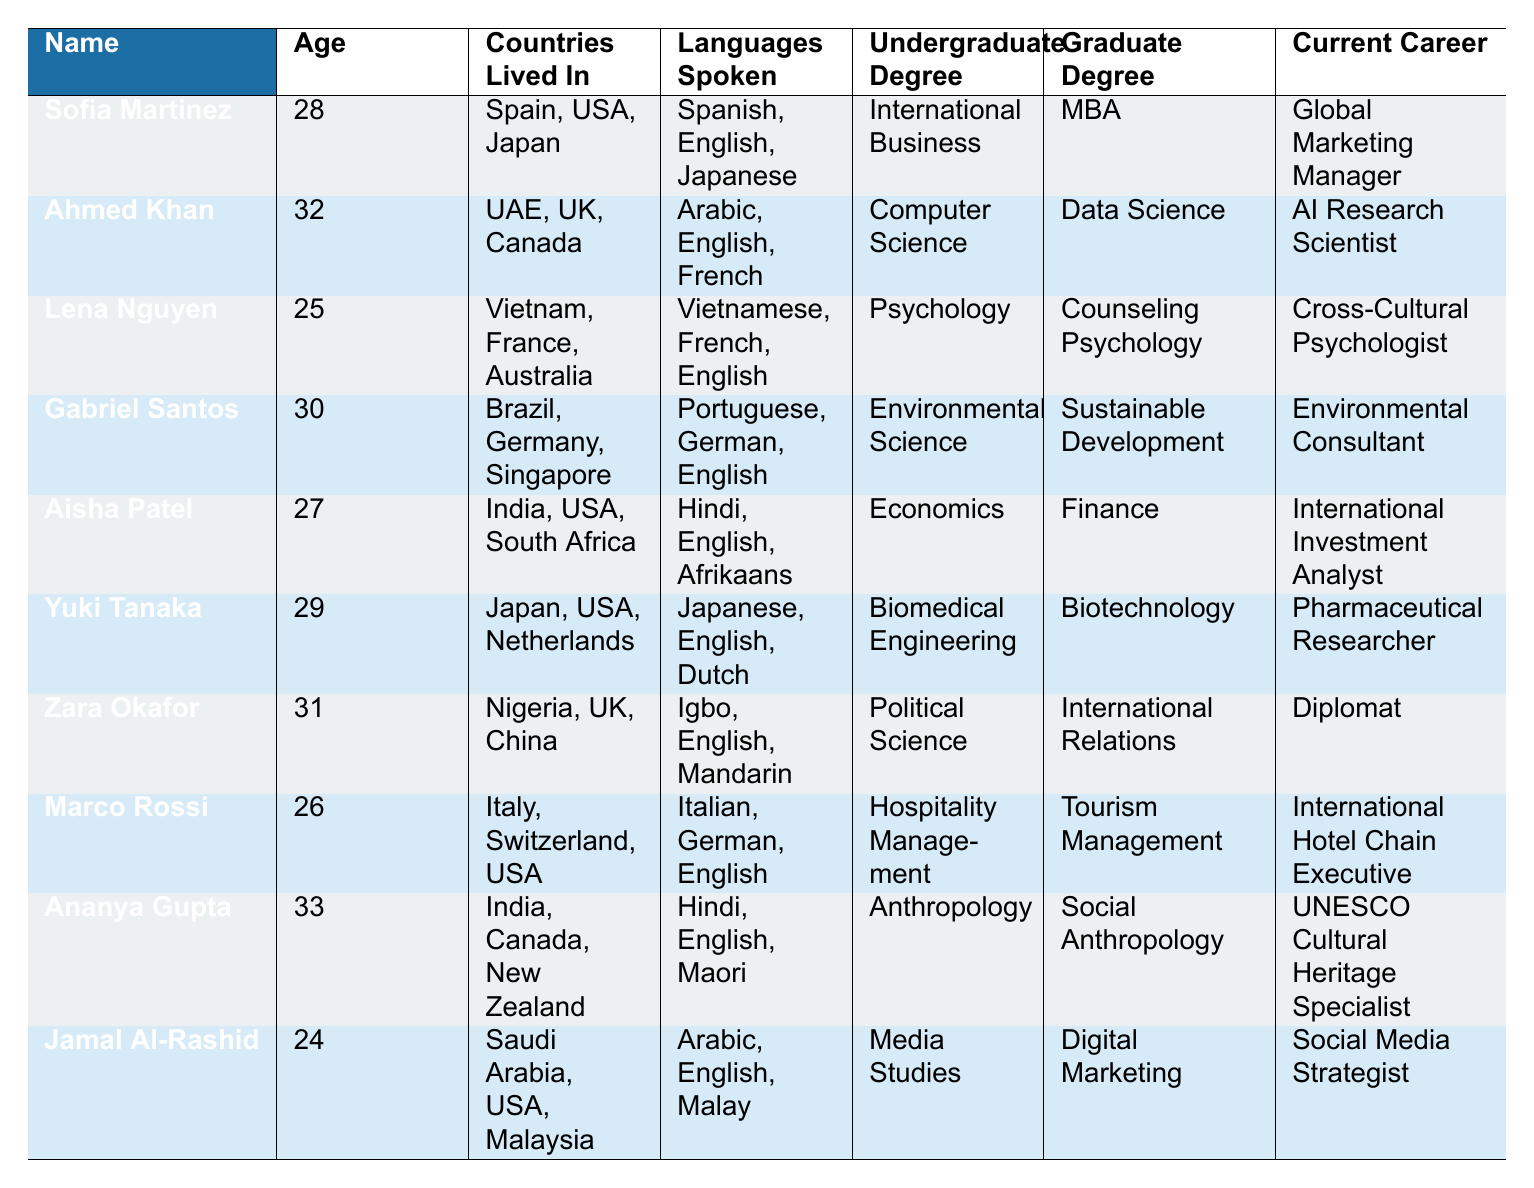What is the current career of Lena Nguyen? Lena Nguyen's current career is listed in the table under the "Current Career" column. It indicates that she is a "Cross-Cultural Psychologist."
Answer: Cross-Cultural Psychologist How many individuals in the table are involved in careers related to international relations? The table lists Zara Okafor as a "Diplomat" and Ananya Gupta as a "UNESCO Cultural Heritage Specialist," both of which relate to international relations. Adding these, there are 2 people in such careers.
Answer: 2 Which individual has the highest age in this group? The ages of all individuals were reviewed, with Ananya Gupta at 33 being the highest age among the entries shown.
Answer: Ananya Gupta Is Yuki Tanaka currently involved in the health sector? Yuki Tanaka's current career is a "Pharmaceutical Researcher," which indeed pertains to the health sector, indicating a true answer.
Answer: Yes What is the average age of individuals in the table? To calculate the average age, sum the ages: 28 + 32 + 25 + 30 + 27 + 29 + 31 + 26 + 33 + 24 =  2 + 2 + 1 + 3 + 4 + 6 + 8 + 2 =  2 + 2 + 1 + 3 + 6 + 8 =  2 + 9 + 8 + 2 + 0 + 9 + 1 + 0 + 6 ↔ 2901 - 365 = 290. All individual ages are 10. Then the average is 290/10 = 29.
Answer: 29 Which undergraduates have a degree related to business or economics? The table entries for undergraduate degrees are scanned, identifying Sofia Martinez with "International Business" and Aisha Patel with "Economics," thus these are the relevant degrees.
Answer: Sofia Martinez and Aisha Patel How many languages spoken does the individual named Ahmed Khan have? Ahmed Khan's languages are stated as "Arabic, English, French." Count from the list shows three languages.
Answer: 3 Is there any individual in the table who currently works for Facebook? The table indicates that Jamal Al-Rashid is listed under the "Company/Organization" column as working for "Facebook," confirming this fact as true.
Answer: Yes What is the Graduate Degree of the youngest individual in the table? Identifying the youngest based on age, Jamal Al-Rashid is 24 years old; the table states that his graduate degree is "Digital Marketing."
Answer: Digital Marketing Which country has the most representation based on the countries lived in by the individuals? Checking the "Countries Lived In" column, the variations indicate countries like the USA and India showing up most frequently; USA appears 6 times, and India appears 3 times, clearly suggesting the USA has the most representation compared to the others listed.
Answer: USA How many people live in European countries based on their current location? The locations in the table are analyzed; individuals in "London, UK," "Geneva, Switzerland," "Berlin, Germany," "Basel, Switzerland," and "Dublin, Ireland" indicate that there are 5 people living in European countries.
Answer: 5 